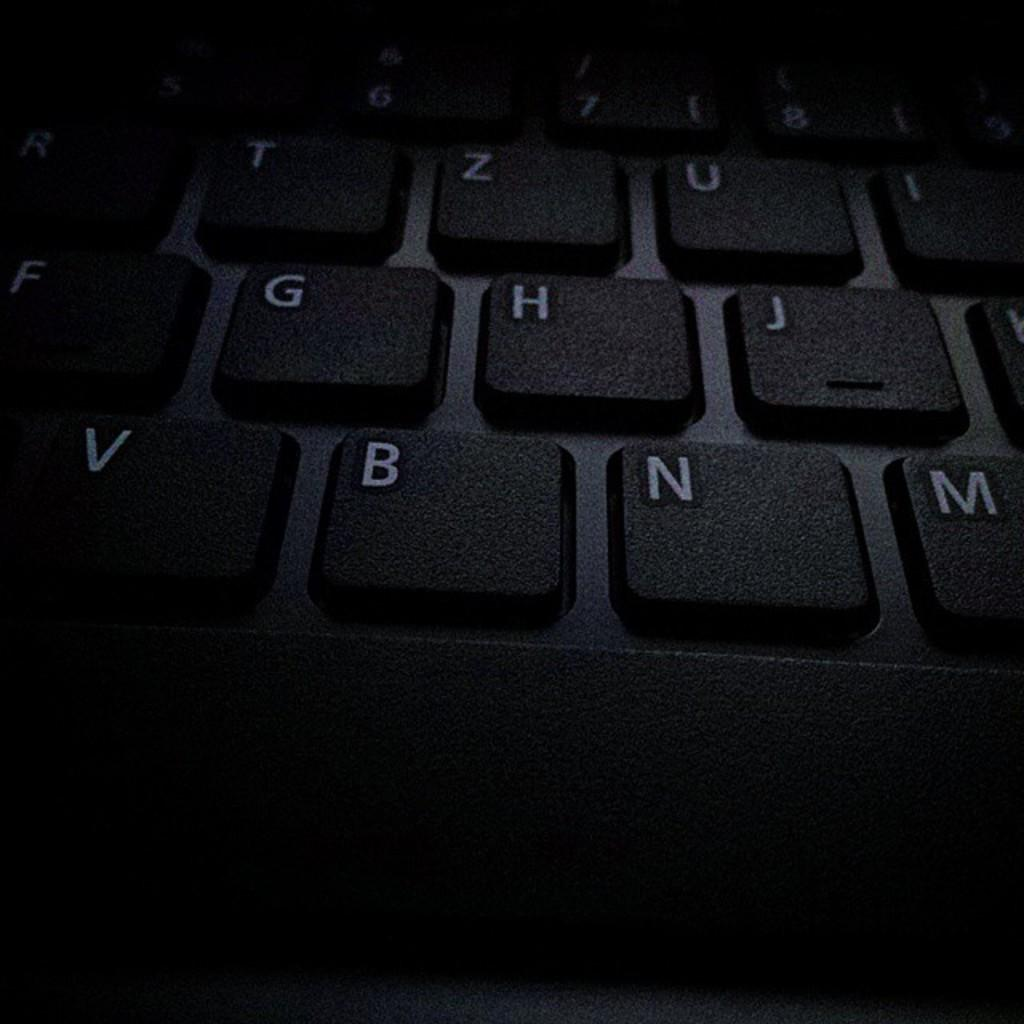Provide a one-sentence caption for the provided image. A dark hued view of a keyboard including the B and N keys. 